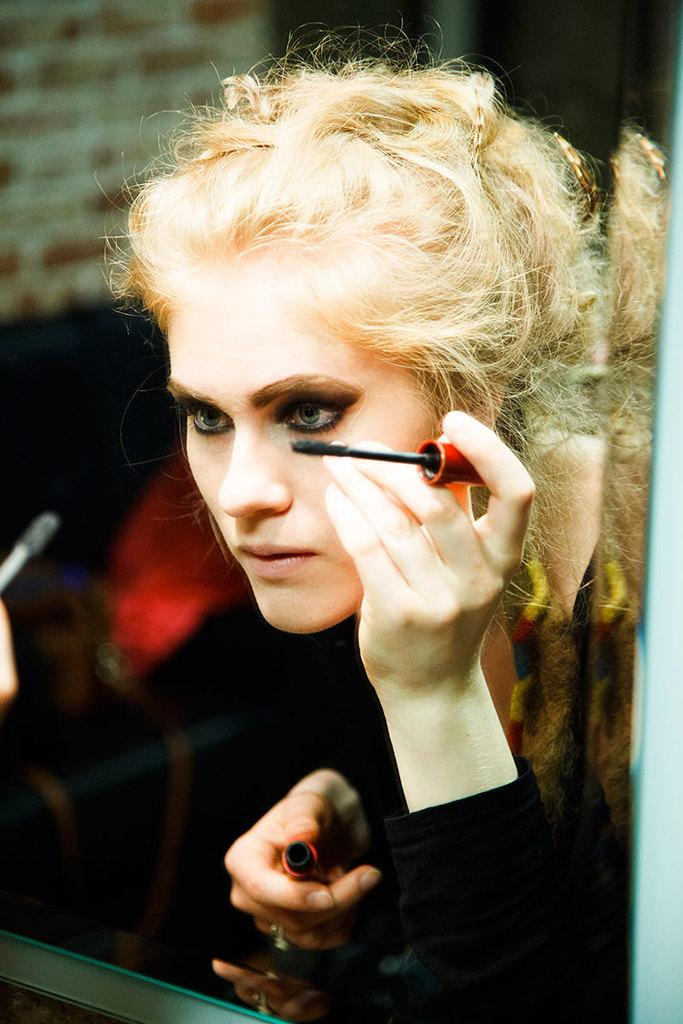Who is present in the image? There is a woman in the image. What is the woman doing in the image? The woman is standing in front of a mirror. What is the woman holding in the image? The woman is holding cosmetics. What type of toys can be seen in the image? There are no toys present in the image. How does the woman use the spade in the image? There is no spade present in the image. 